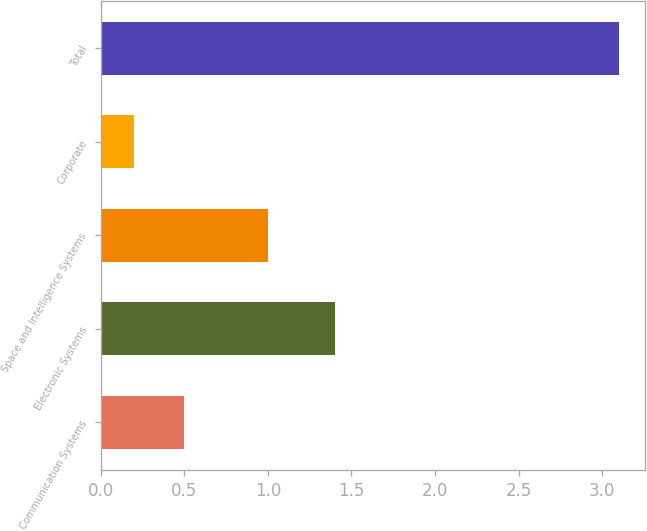Convert chart to OTSL. <chart><loc_0><loc_0><loc_500><loc_500><bar_chart><fcel>Communication Systems<fcel>Electronic Systems<fcel>Space and Intelligence Systems<fcel>Corporate<fcel>Total<nl><fcel>0.5<fcel>1.4<fcel>1<fcel>0.2<fcel>3.1<nl></chart> 